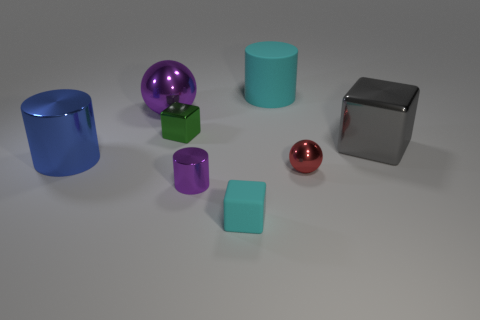There is a big blue cylinder; are there any small green metal blocks in front of it?
Ensure brevity in your answer.  No. Are there any large purple cubes that have the same material as the purple ball?
Make the answer very short. No. There is a rubber object that is the same color as the large rubber cylinder; what is its size?
Offer a terse response. Small. What number of cylinders are either tiny rubber things or large purple metal objects?
Offer a terse response. 0. Is the number of green shiny objects that are to the right of the large rubber cylinder greater than the number of cubes that are on the right side of the small purple metallic cylinder?
Your answer should be compact. No. What number of metal objects have the same color as the small metal cylinder?
Make the answer very short. 1. What size is the cylinder that is made of the same material as the large blue object?
Your answer should be very brief. Small. How many things are either purple objects that are in front of the gray object or big gray shiny blocks?
Ensure brevity in your answer.  2. There is a tiny block behind the gray shiny cube; is its color the same as the tiny shiny cylinder?
Provide a succinct answer. No. There is a green object that is the same shape as the gray metallic thing; what size is it?
Offer a very short reply. Small. 